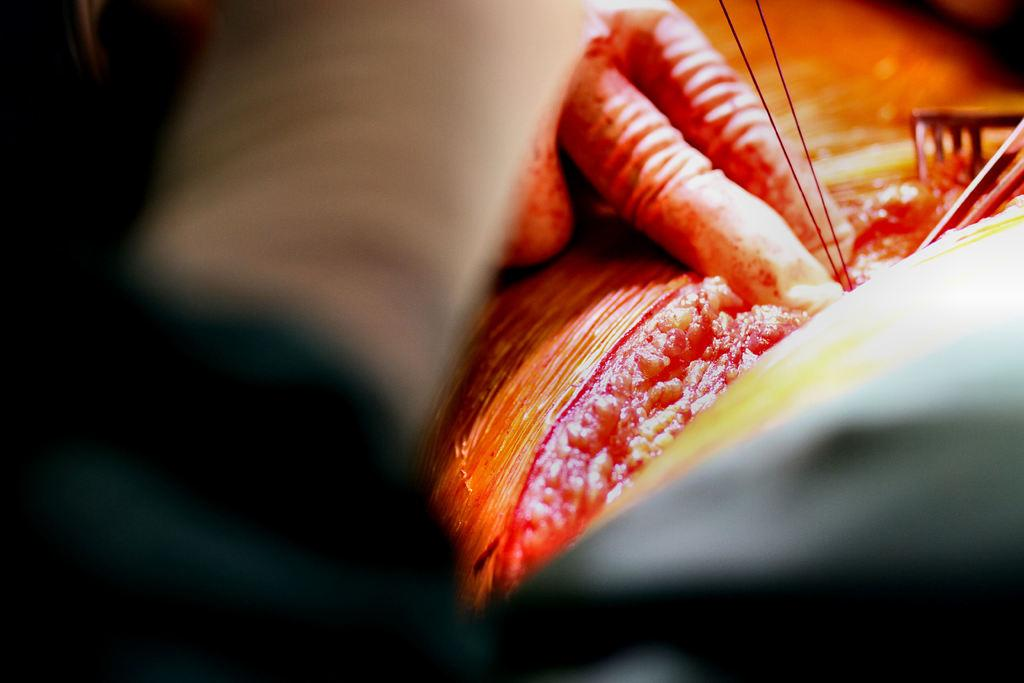What body part is visible in the image? There are a person's fingers in the image. What type of material can be seen in the image? There are threads in the image. What else can be seen in the image besides the fingers and threads? There are some objects in the image. What does the creature say to the person's fingers in the image? There is no creature present in the image, so it cannot say anything to the person's fingers. 